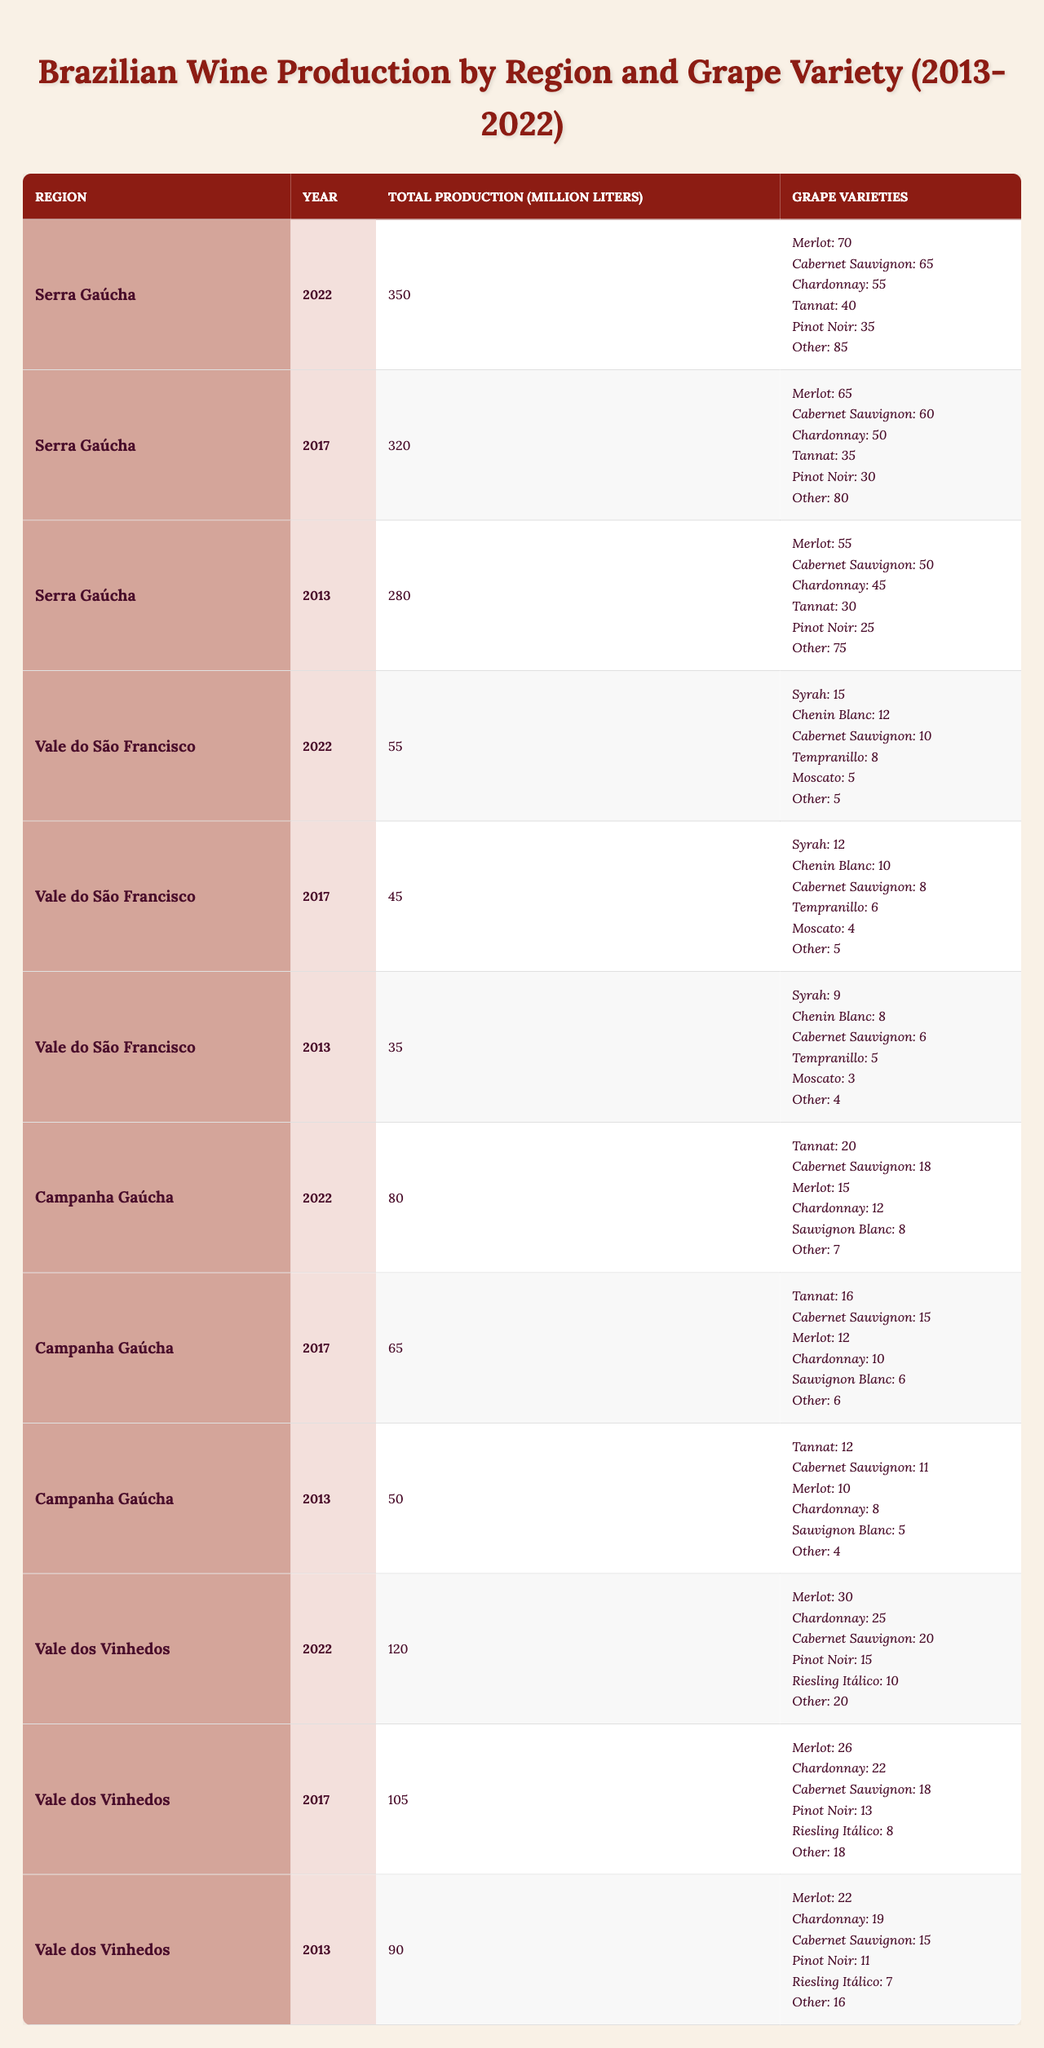What was the total wine production in Serra Gaúcha in 2022? In the table, for the region Serra Gaúcha in the year 2022, the total production listed is 350 million liters.
Answer: 350 million liters What grape variety had the highest production in Vale dos Vinhedos in 2022? The grape variety with the highest production in Vale dos Vinhedos in 2022 is Merlot, with a production of 30 million liters.
Answer: Merlot How much has the total wine production increased in Campanha Gaúcha from 2013 to 2022? The total production in Campanha Gaúcha was 50 million liters in 2013 and increased to 80 million liters in 2022. The difference is 80 - 50 = 30 million liters.
Answer: 30 million liters Which region had the lowest total production in 2013? In 2013, the region with the lowest total production was Vale do São Francisco, producing 35 million liters, compared to other regions.
Answer: Vale do São Francisco What percentage of total production in Serra Gaúcha in 2022 was contributed by Cabernet Sauvignon? The total production in Serra Gaúcha in 2022 was 350 million liters, and Cabernet Sauvignon produced 65 million liters. To find the percentage, calculate (65/350) * 100 = 18.57%.
Answer: 18.57% Did Vale dos Vinhedos produce more wine than Campanha Gaúcha in 2017? In 2017, Vale dos Vinhedos produced 105 million liters, while Campanha Gaúcha produced 65 million liters, which means Vale dos Vinhedos produced more wine.
Answer: Yes What is the average total wine production in the Vale do São Francisco over the years 2013 to 2022? The total production values for the years are 35 (2013), 45 (2017), and 55 (2022), adding them gives 35 + 45 + 55 = 135 million liters. Dividing by 3 gives an average of 135 / 3 = 45 million liters per year.
Answer: 45 million liters Which grape variety showed an increase in production from 2013 to 2022 in Serra Gaúcha? Comparing the years, Merlot production increased from 55 million liters in 2013 to 70 million liters in 2022, showing an increase of 15 million liters.
Answer: Merlot How much was the total production of Chardonnay in Campanha Gaúcha from 2013 to 2022 combined? The production of Chardonnay in Campanha Gaúcha was 8 million liters in 2013, 10 million liters in 2017, and 12 million liters in 2022, summing these gives 8 + 10 + 12 = 30 million liters.
Answer: 30 million liters Are there any years where the total production in Vale dos Vinhedos was below 100 million liters? Reviewing the data, Vale dos Vinhedos produced 90 million liters in 2013 and 105 million liters in 2017 and 2022, which indicates that there is one year (2013) when the production was below 100 million liters.
Answer: Yes 